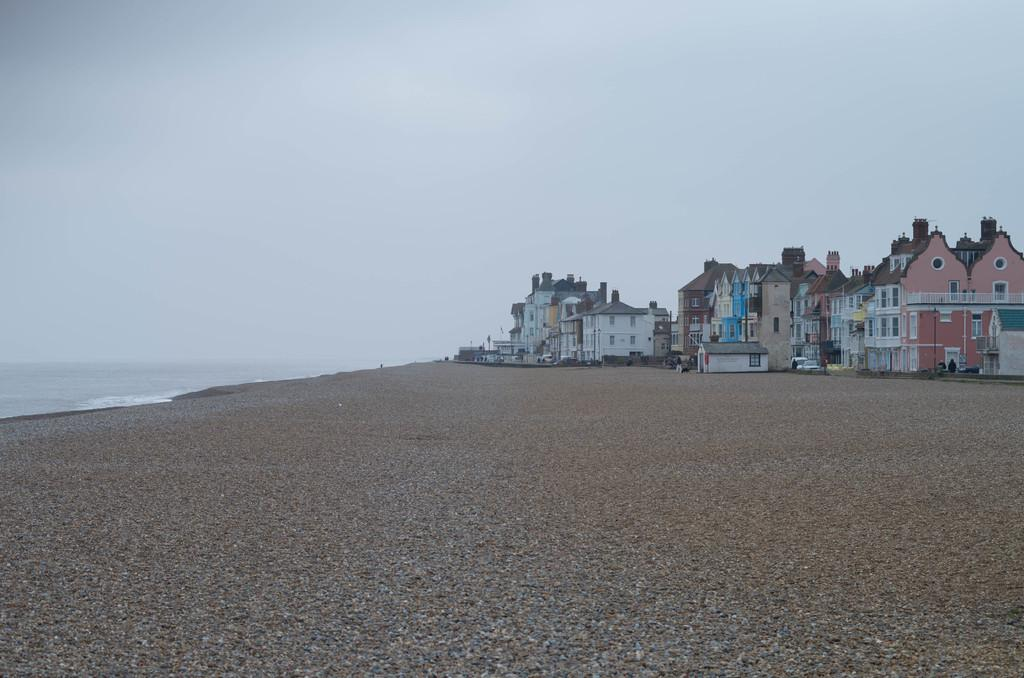What is located in the foreground of the image? There are stones in the foreground of the image. What can be seen in the background of the image? There are buildings, cars, water, and the sky visible in the background of the image. Can you describe the type of structures in the background? The buildings in the background are likely man-made structures, such as houses or commercial buildings. How many types of objects can be seen in the background? There are at least four types of objects visible in the background: buildings, cars, water, and the sky. Can you see any pipes in the image? There are no pipes visible in the image. Is there a quince tree in the image? There is no quince tree present in the image. 